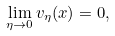Convert formula to latex. <formula><loc_0><loc_0><loc_500><loc_500>\lim _ { \eta \to 0 } v _ { \eta } ( x ) = 0 ,</formula> 